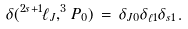<formula> <loc_0><loc_0><loc_500><loc_500>\delta ( ^ { 2 s + 1 } \ell _ { J } , ^ { 3 } P _ { 0 } ) \, = \, \delta _ { J 0 } \delta _ { \ell 1 } \delta _ { s 1 } \, .</formula> 